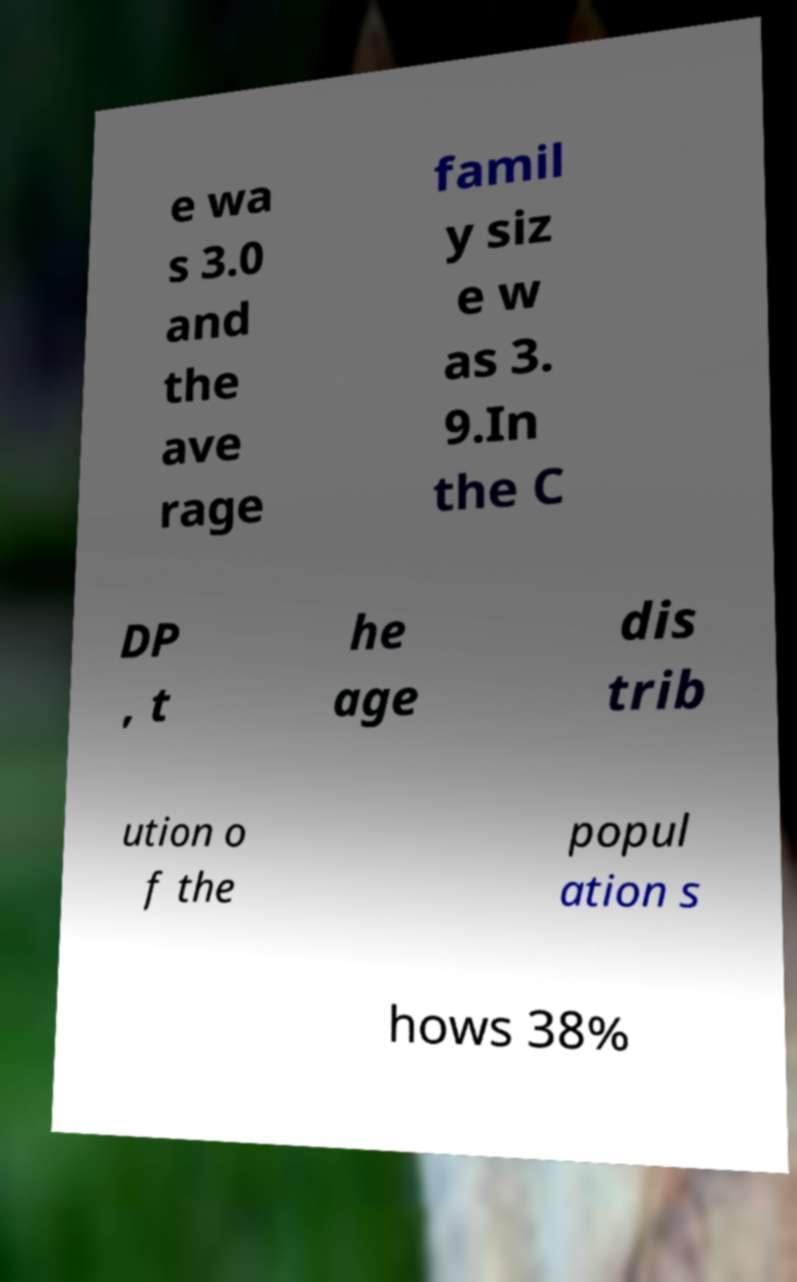Could you extract and type out the text from this image? e wa s 3.0 and the ave rage famil y siz e w as 3. 9.In the C DP , t he age dis trib ution o f the popul ation s hows 38% 